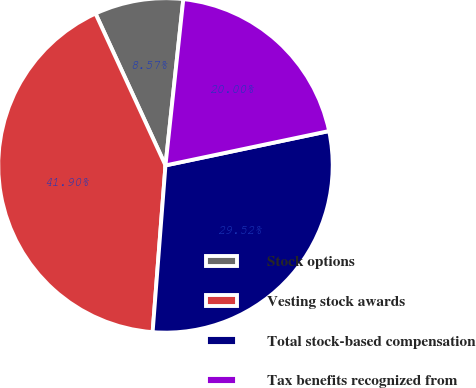Convert chart. <chart><loc_0><loc_0><loc_500><loc_500><pie_chart><fcel>Stock options<fcel>Vesting stock awards<fcel>Total stock-based compensation<fcel>Tax benefits recognized from<nl><fcel>8.57%<fcel>41.9%<fcel>29.52%<fcel>20.0%<nl></chart> 